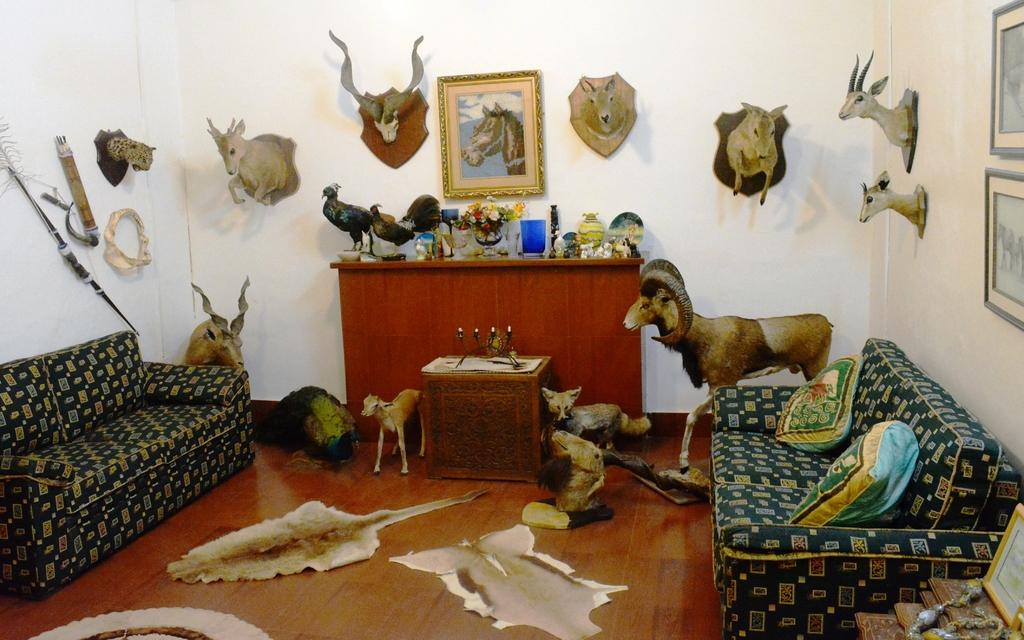What type of furniture is present in the image? There is a couch and a table in the image. What other objects can be seen in the image? There are animal statues in the image. Is there any decoration on the wall in the image? Yes, there is a frame on the wall in the image. Can you tell me the answer to the question that is being asked in the image? There is no question being asked in the image, so there is no answer to provide. 